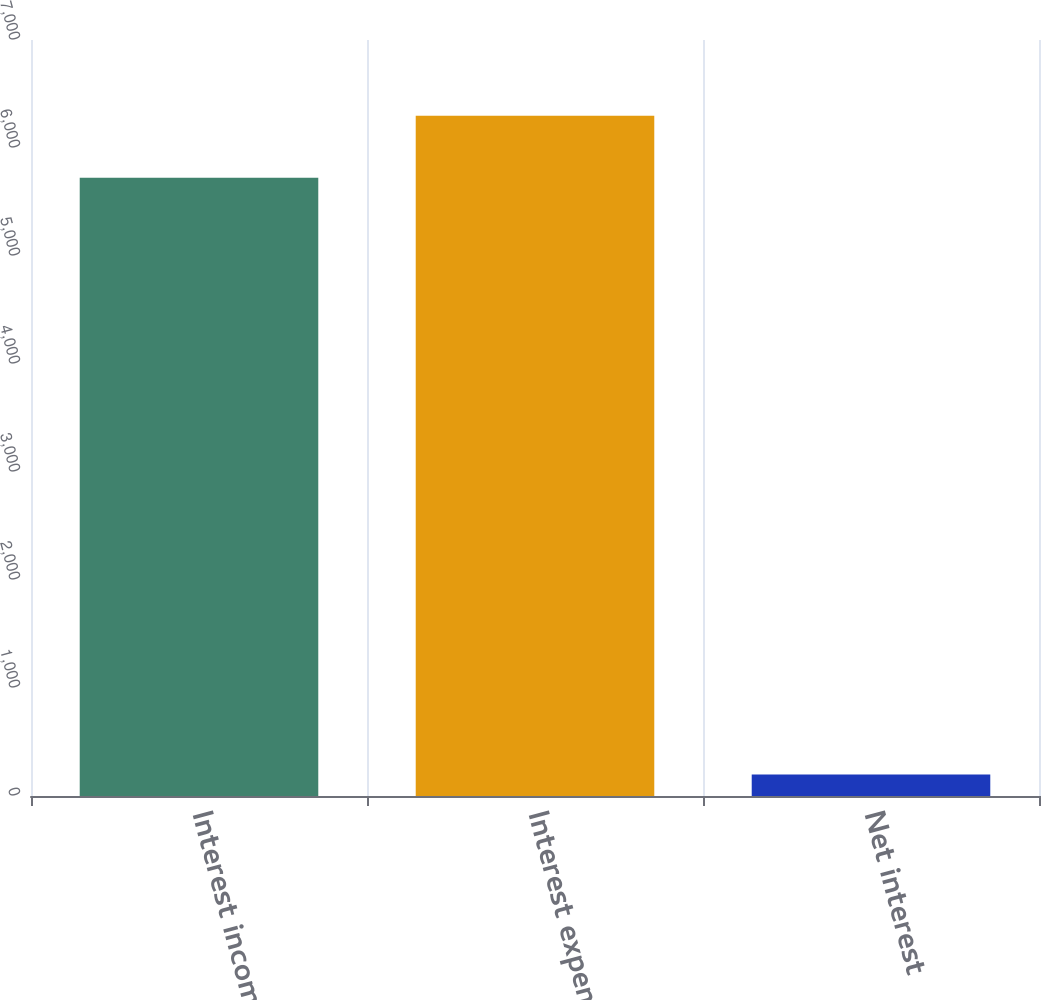Convert chart to OTSL. <chart><loc_0><loc_0><loc_500><loc_500><bar_chart><fcel>Interest income<fcel>Interest expense<fcel>Net interest<nl><fcel>5725<fcel>6297.5<fcel>199<nl></chart> 